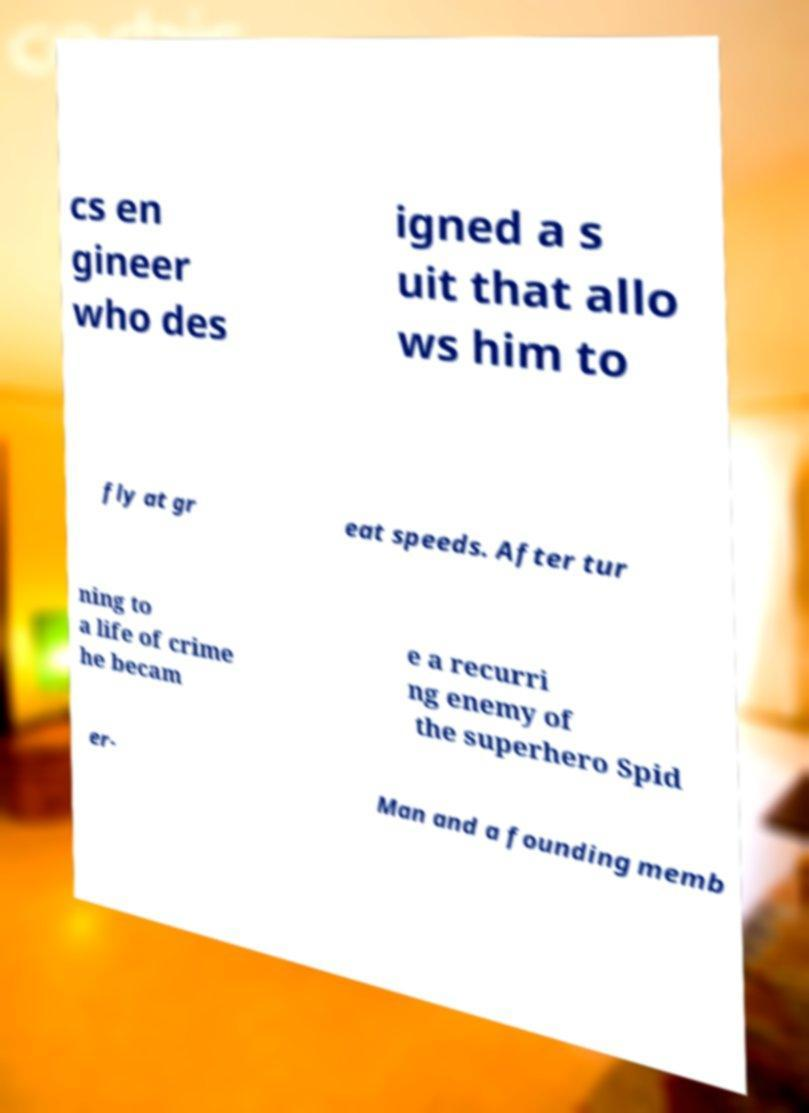Can you accurately transcribe the text from the provided image for me? cs en gineer who des igned a s uit that allo ws him to fly at gr eat speeds. After tur ning to a life of crime he becam e a recurri ng enemy of the superhero Spid er- Man and a founding memb 